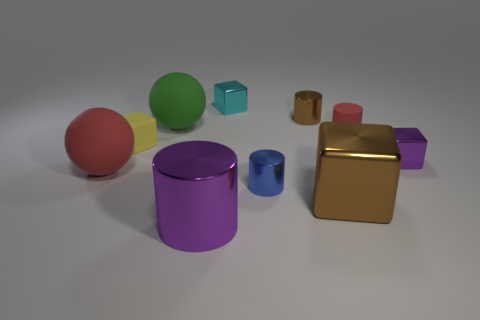What number of brown things are tiny cylinders or big things?
Keep it short and to the point. 2. There is a big brown shiny object; are there any tiny cyan metallic objects on the right side of it?
Give a very brief answer. No. What is the size of the blue cylinder?
Provide a succinct answer. Small. There is a purple shiny thing that is the same shape as the small yellow rubber thing; what size is it?
Give a very brief answer. Small. There is a brown thing that is in front of the tiny brown cylinder; what number of small yellow things are right of it?
Offer a terse response. 0. Are the small yellow block that is on the right side of the red matte ball and the big thing that is on the right side of the big metallic cylinder made of the same material?
Provide a succinct answer. No. How many green things are the same shape as the large red thing?
Offer a very short reply. 1. How many rubber balls have the same color as the rubber cylinder?
Keep it short and to the point. 1. There is a rubber thing on the right side of the big purple object; does it have the same shape as the brown metallic object behind the small yellow matte object?
Ensure brevity in your answer.  Yes. What number of blue cylinders are behind the big brown block that is right of the cylinder in front of the blue cylinder?
Give a very brief answer. 1. 